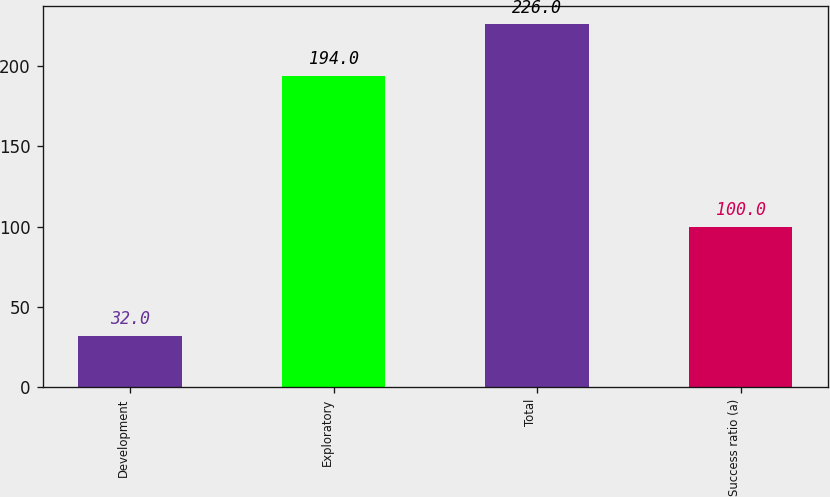Convert chart. <chart><loc_0><loc_0><loc_500><loc_500><bar_chart><fcel>Development<fcel>Exploratory<fcel>Total<fcel>Success ratio (a)<nl><fcel>32<fcel>194<fcel>226<fcel>100<nl></chart> 